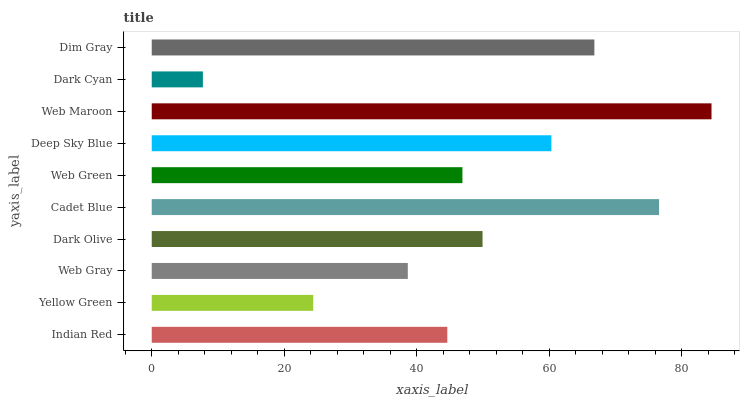Is Dark Cyan the minimum?
Answer yes or no. Yes. Is Web Maroon the maximum?
Answer yes or no. Yes. Is Yellow Green the minimum?
Answer yes or no. No. Is Yellow Green the maximum?
Answer yes or no. No. Is Indian Red greater than Yellow Green?
Answer yes or no. Yes. Is Yellow Green less than Indian Red?
Answer yes or no. Yes. Is Yellow Green greater than Indian Red?
Answer yes or no. No. Is Indian Red less than Yellow Green?
Answer yes or no. No. Is Dark Olive the high median?
Answer yes or no. Yes. Is Web Green the low median?
Answer yes or no. Yes. Is Indian Red the high median?
Answer yes or no. No. Is Dark Olive the low median?
Answer yes or no. No. 